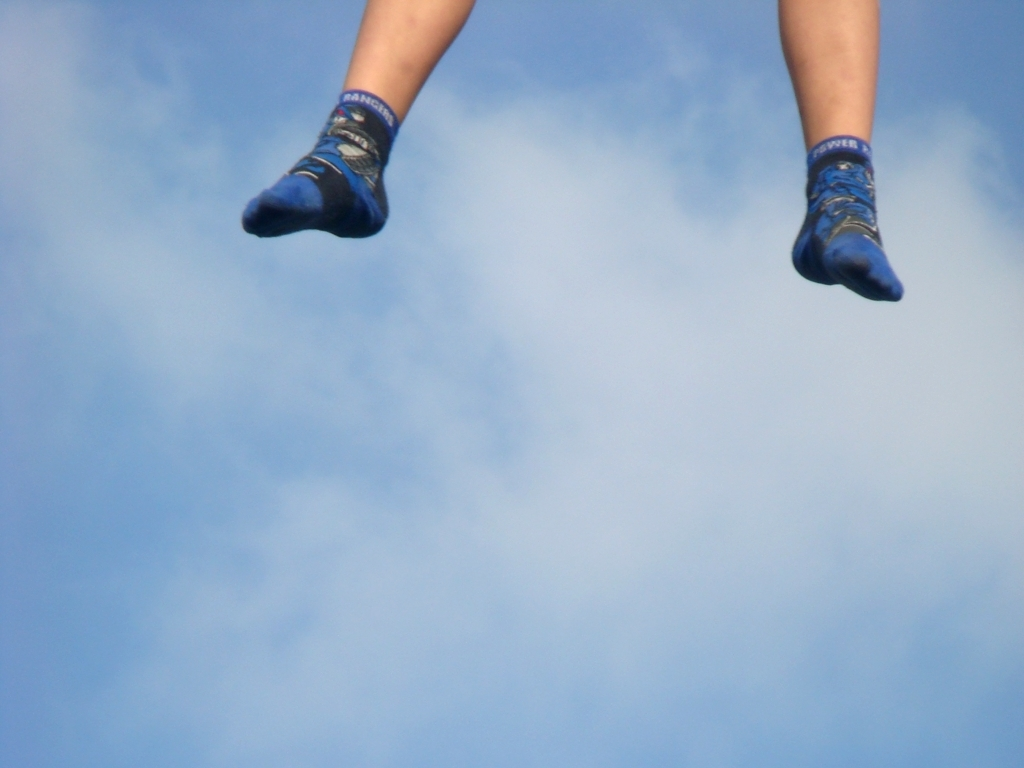What is unique about the position of the socks? The socks are captured in mid-air, giving the impression that someone is either jumping very high or is in the midst of an action shot. The lack of any other part of the person or background objects makes it a playful and intriguing photograph, focused solely on the excitement suggested by the 'floating' socks. 